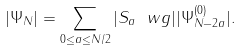<formula> <loc_0><loc_0><loc_500><loc_500>| \Psi _ { N } | = \sum _ { 0 \leq a \leq N / 2 } | S _ { a } \ w g | | \Psi ^ { ( 0 ) } _ { N - 2 a } | .</formula> 